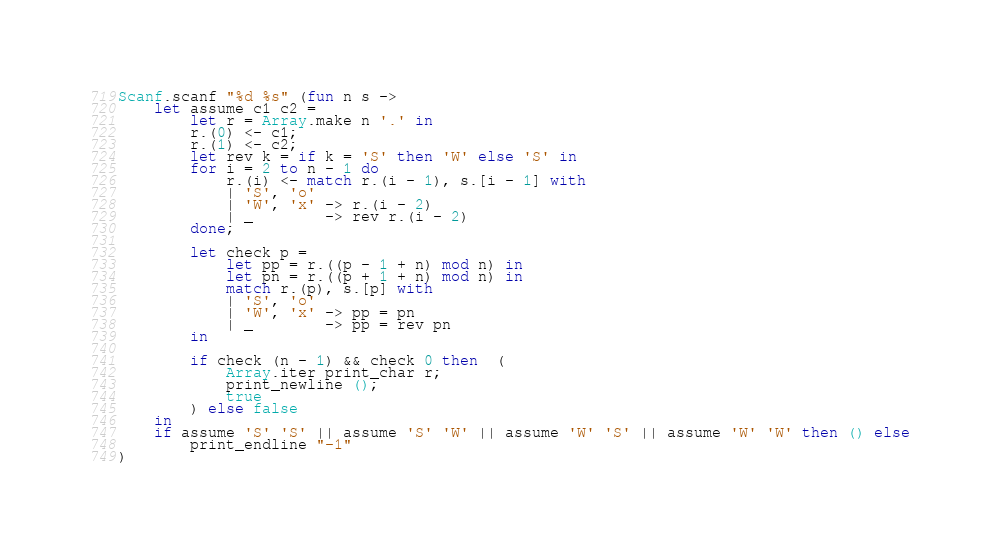<code> <loc_0><loc_0><loc_500><loc_500><_OCaml_>Scanf.scanf "%d %s" (fun n s ->
    let assume c1 c2 =
        let r = Array.make n '.' in
        r.(0) <- c1;
        r.(1) <- c2;
        let rev k = if k = 'S' then 'W' else 'S' in
        for i = 2 to n - 1 do
            r.(i) <- match r.(i - 1), s.[i - 1] with
            | 'S', 'o' 
            | 'W', 'x' -> r.(i - 2)
            | _        -> rev r.(i - 2)
        done;

        let check p =
            let pp = r.((p - 1 + n) mod n) in
            let pn = r.((p + 1 + n) mod n) in
            match r.(p), s.[p] with
            | 'S', 'o'
            | 'W', 'x' -> pp = pn
            | _        -> pp = rev pn
        in

        if check (n - 1) && check 0 then  (
            Array.iter print_char r;
            print_newline ();
            true
        ) else false
    in
    if assume 'S' 'S' || assume 'S' 'W' || assume 'W' 'S' || assume 'W' 'W' then () else
        print_endline "-1"
)</code> 